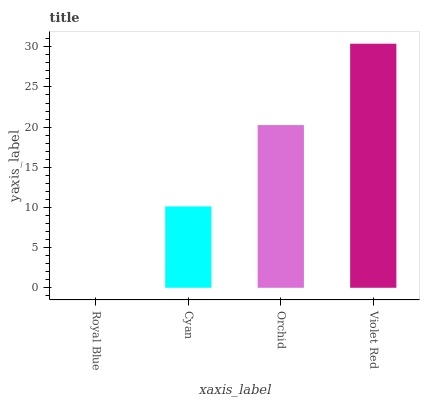Is Royal Blue the minimum?
Answer yes or no. Yes. Is Violet Red the maximum?
Answer yes or no. Yes. Is Cyan the minimum?
Answer yes or no. No. Is Cyan the maximum?
Answer yes or no. No. Is Cyan greater than Royal Blue?
Answer yes or no. Yes. Is Royal Blue less than Cyan?
Answer yes or no. Yes. Is Royal Blue greater than Cyan?
Answer yes or no. No. Is Cyan less than Royal Blue?
Answer yes or no. No. Is Orchid the high median?
Answer yes or no. Yes. Is Cyan the low median?
Answer yes or no. Yes. Is Royal Blue the high median?
Answer yes or no. No. Is Royal Blue the low median?
Answer yes or no. No. 